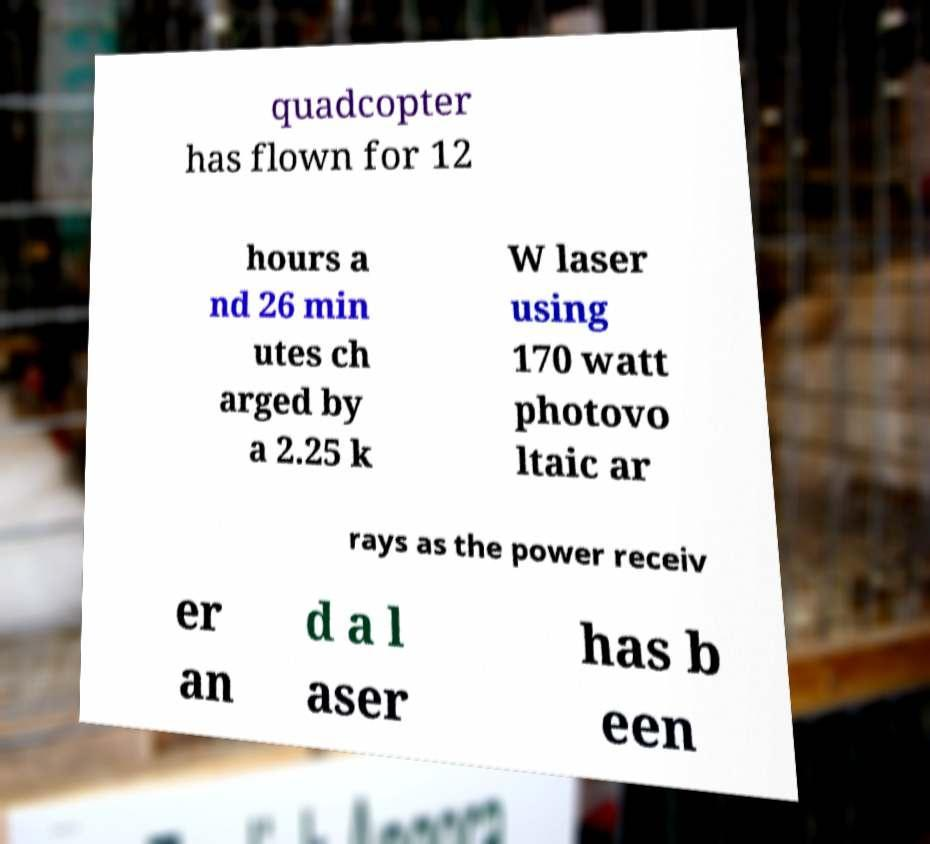For documentation purposes, I need the text within this image transcribed. Could you provide that? quadcopter has flown for 12 hours a nd 26 min utes ch arged by a 2.25 k W laser using 170 watt photovo ltaic ar rays as the power receiv er an d a l aser has b een 